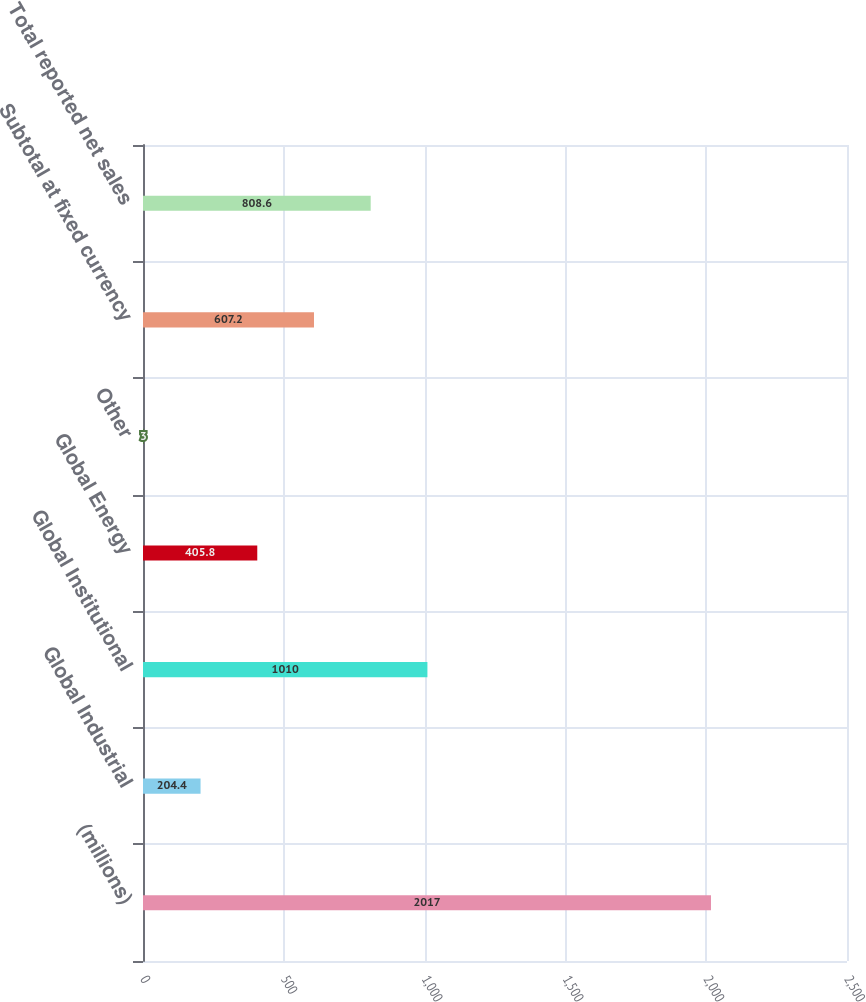Convert chart to OTSL. <chart><loc_0><loc_0><loc_500><loc_500><bar_chart><fcel>(millions)<fcel>Global Industrial<fcel>Global Institutional<fcel>Global Energy<fcel>Other<fcel>Subtotal at fixed currency<fcel>Total reported net sales<nl><fcel>2017<fcel>204.4<fcel>1010<fcel>405.8<fcel>3<fcel>607.2<fcel>808.6<nl></chart> 